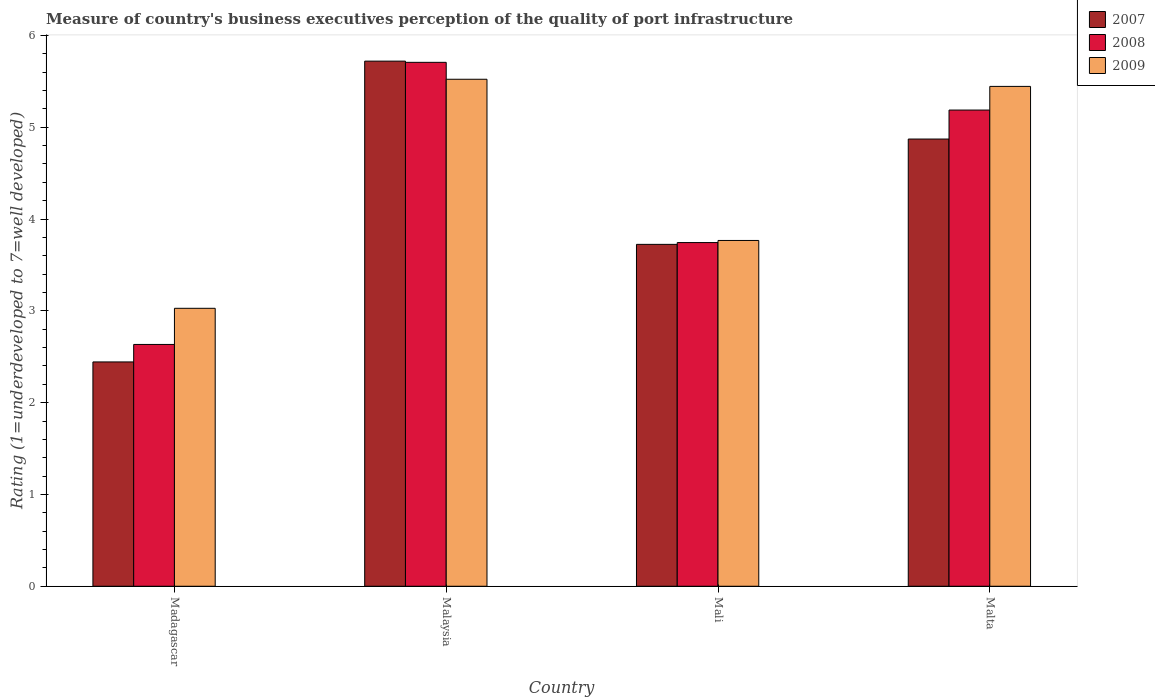How many groups of bars are there?
Your answer should be compact. 4. Are the number of bars per tick equal to the number of legend labels?
Make the answer very short. Yes. How many bars are there on the 2nd tick from the left?
Your response must be concise. 3. How many bars are there on the 2nd tick from the right?
Offer a very short reply. 3. What is the label of the 3rd group of bars from the left?
Offer a very short reply. Mali. In how many cases, is the number of bars for a given country not equal to the number of legend labels?
Provide a short and direct response. 0. What is the ratings of the quality of port infrastructure in 2009 in Malaysia?
Provide a succinct answer. 5.52. Across all countries, what is the maximum ratings of the quality of port infrastructure in 2009?
Offer a terse response. 5.52. Across all countries, what is the minimum ratings of the quality of port infrastructure in 2007?
Provide a short and direct response. 2.44. In which country was the ratings of the quality of port infrastructure in 2007 maximum?
Provide a short and direct response. Malaysia. In which country was the ratings of the quality of port infrastructure in 2007 minimum?
Your answer should be very brief. Madagascar. What is the total ratings of the quality of port infrastructure in 2007 in the graph?
Your answer should be compact. 16.76. What is the difference between the ratings of the quality of port infrastructure in 2009 in Madagascar and that in Malaysia?
Offer a terse response. -2.5. What is the difference between the ratings of the quality of port infrastructure in 2009 in Malta and the ratings of the quality of port infrastructure in 2007 in Madagascar?
Make the answer very short. 3. What is the average ratings of the quality of port infrastructure in 2008 per country?
Make the answer very short. 4.32. What is the difference between the ratings of the quality of port infrastructure of/in 2009 and ratings of the quality of port infrastructure of/in 2007 in Malaysia?
Offer a very short reply. -0.2. What is the ratio of the ratings of the quality of port infrastructure in 2009 in Madagascar to that in Mali?
Ensure brevity in your answer.  0.8. What is the difference between the highest and the second highest ratings of the quality of port infrastructure in 2008?
Keep it short and to the point. 1.44. What is the difference between the highest and the lowest ratings of the quality of port infrastructure in 2008?
Ensure brevity in your answer.  3.07. In how many countries, is the ratings of the quality of port infrastructure in 2007 greater than the average ratings of the quality of port infrastructure in 2007 taken over all countries?
Provide a succinct answer. 2. What does the 3rd bar from the left in Madagascar represents?
Ensure brevity in your answer.  2009. Are all the bars in the graph horizontal?
Your answer should be compact. No. Does the graph contain any zero values?
Your response must be concise. No. How are the legend labels stacked?
Your answer should be very brief. Vertical. What is the title of the graph?
Offer a very short reply. Measure of country's business executives perception of the quality of port infrastructure. Does "2014" appear as one of the legend labels in the graph?
Your answer should be very brief. No. What is the label or title of the Y-axis?
Your answer should be compact. Rating (1=underdeveloped to 7=well developed). What is the Rating (1=underdeveloped to 7=well developed) in 2007 in Madagascar?
Ensure brevity in your answer.  2.44. What is the Rating (1=underdeveloped to 7=well developed) of 2008 in Madagascar?
Offer a very short reply. 2.63. What is the Rating (1=underdeveloped to 7=well developed) of 2009 in Madagascar?
Provide a succinct answer. 3.03. What is the Rating (1=underdeveloped to 7=well developed) of 2007 in Malaysia?
Give a very brief answer. 5.72. What is the Rating (1=underdeveloped to 7=well developed) in 2008 in Malaysia?
Provide a succinct answer. 5.71. What is the Rating (1=underdeveloped to 7=well developed) in 2009 in Malaysia?
Your answer should be very brief. 5.52. What is the Rating (1=underdeveloped to 7=well developed) of 2007 in Mali?
Provide a short and direct response. 3.72. What is the Rating (1=underdeveloped to 7=well developed) in 2008 in Mali?
Your answer should be compact. 3.74. What is the Rating (1=underdeveloped to 7=well developed) of 2009 in Mali?
Provide a succinct answer. 3.77. What is the Rating (1=underdeveloped to 7=well developed) in 2007 in Malta?
Your answer should be very brief. 4.87. What is the Rating (1=underdeveloped to 7=well developed) of 2008 in Malta?
Your response must be concise. 5.19. What is the Rating (1=underdeveloped to 7=well developed) of 2009 in Malta?
Your answer should be very brief. 5.44. Across all countries, what is the maximum Rating (1=underdeveloped to 7=well developed) in 2007?
Ensure brevity in your answer.  5.72. Across all countries, what is the maximum Rating (1=underdeveloped to 7=well developed) of 2008?
Provide a succinct answer. 5.71. Across all countries, what is the maximum Rating (1=underdeveloped to 7=well developed) in 2009?
Make the answer very short. 5.52. Across all countries, what is the minimum Rating (1=underdeveloped to 7=well developed) in 2007?
Your response must be concise. 2.44. Across all countries, what is the minimum Rating (1=underdeveloped to 7=well developed) in 2008?
Provide a succinct answer. 2.63. Across all countries, what is the minimum Rating (1=underdeveloped to 7=well developed) in 2009?
Your response must be concise. 3.03. What is the total Rating (1=underdeveloped to 7=well developed) of 2007 in the graph?
Offer a terse response. 16.76. What is the total Rating (1=underdeveloped to 7=well developed) of 2008 in the graph?
Make the answer very short. 17.27. What is the total Rating (1=underdeveloped to 7=well developed) in 2009 in the graph?
Your response must be concise. 17.76. What is the difference between the Rating (1=underdeveloped to 7=well developed) of 2007 in Madagascar and that in Malaysia?
Your answer should be compact. -3.28. What is the difference between the Rating (1=underdeveloped to 7=well developed) of 2008 in Madagascar and that in Malaysia?
Your answer should be very brief. -3.07. What is the difference between the Rating (1=underdeveloped to 7=well developed) in 2009 in Madagascar and that in Malaysia?
Ensure brevity in your answer.  -2.5. What is the difference between the Rating (1=underdeveloped to 7=well developed) in 2007 in Madagascar and that in Mali?
Provide a short and direct response. -1.28. What is the difference between the Rating (1=underdeveloped to 7=well developed) of 2008 in Madagascar and that in Mali?
Provide a short and direct response. -1.11. What is the difference between the Rating (1=underdeveloped to 7=well developed) of 2009 in Madagascar and that in Mali?
Ensure brevity in your answer.  -0.74. What is the difference between the Rating (1=underdeveloped to 7=well developed) in 2007 in Madagascar and that in Malta?
Provide a succinct answer. -2.43. What is the difference between the Rating (1=underdeveloped to 7=well developed) of 2008 in Madagascar and that in Malta?
Your response must be concise. -2.55. What is the difference between the Rating (1=underdeveloped to 7=well developed) of 2009 in Madagascar and that in Malta?
Offer a terse response. -2.42. What is the difference between the Rating (1=underdeveloped to 7=well developed) in 2007 in Malaysia and that in Mali?
Give a very brief answer. 2. What is the difference between the Rating (1=underdeveloped to 7=well developed) in 2008 in Malaysia and that in Mali?
Offer a terse response. 1.96. What is the difference between the Rating (1=underdeveloped to 7=well developed) of 2009 in Malaysia and that in Mali?
Keep it short and to the point. 1.76. What is the difference between the Rating (1=underdeveloped to 7=well developed) of 2007 in Malaysia and that in Malta?
Offer a terse response. 0.85. What is the difference between the Rating (1=underdeveloped to 7=well developed) in 2008 in Malaysia and that in Malta?
Your answer should be compact. 0.52. What is the difference between the Rating (1=underdeveloped to 7=well developed) of 2009 in Malaysia and that in Malta?
Make the answer very short. 0.08. What is the difference between the Rating (1=underdeveloped to 7=well developed) of 2007 in Mali and that in Malta?
Offer a very short reply. -1.15. What is the difference between the Rating (1=underdeveloped to 7=well developed) of 2008 in Mali and that in Malta?
Make the answer very short. -1.44. What is the difference between the Rating (1=underdeveloped to 7=well developed) of 2009 in Mali and that in Malta?
Offer a terse response. -1.68. What is the difference between the Rating (1=underdeveloped to 7=well developed) in 2007 in Madagascar and the Rating (1=underdeveloped to 7=well developed) in 2008 in Malaysia?
Offer a terse response. -3.26. What is the difference between the Rating (1=underdeveloped to 7=well developed) of 2007 in Madagascar and the Rating (1=underdeveloped to 7=well developed) of 2009 in Malaysia?
Offer a very short reply. -3.08. What is the difference between the Rating (1=underdeveloped to 7=well developed) of 2008 in Madagascar and the Rating (1=underdeveloped to 7=well developed) of 2009 in Malaysia?
Offer a very short reply. -2.89. What is the difference between the Rating (1=underdeveloped to 7=well developed) in 2007 in Madagascar and the Rating (1=underdeveloped to 7=well developed) in 2008 in Mali?
Your answer should be very brief. -1.3. What is the difference between the Rating (1=underdeveloped to 7=well developed) of 2007 in Madagascar and the Rating (1=underdeveloped to 7=well developed) of 2009 in Mali?
Offer a very short reply. -1.32. What is the difference between the Rating (1=underdeveloped to 7=well developed) of 2008 in Madagascar and the Rating (1=underdeveloped to 7=well developed) of 2009 in Mali?
Provide a short and direct response. -1.13. What is the difference between the Rating (1=underdeveloped to 7=well developed) in 2007 in Madagascar and the Rating (1=underdeveloped to 7=well developed) in 2008 in Malta?
Provide a short and direct response. -2.74. What is the difference between the Rating (1=underdeveloped to 7=well developed) in 2007 in Madagascar and the Rating (1=underdeveloped to 7=well developed) in 2009 in Malta?
Your response must be concise. -3. What is the difference between the Rating (1=underdeveloped to 7=well developed) in 2008 in Madagascar and the Rating (1=underdeveloped to 7=well developed) in 2009 in Malta?
Ensure brevity in your answer.  -2.81. What is the difference between the Rating (1=underdeveloped to 7=well developed) of 2007 in Malaysia and the Rating (1=underdeveloped to 7=well developed) of 2008 in Mali?
Your answer should be very brief. 1.98. What is the difference between the Rating (1=underdeveloped to 7=well developed) in 2007 in Malaysia and the Rating (1=underdeveloped to 7=well developed) in 2009 in Mali?
Give a very brief answer. 1.95. What is the difference between the Rating (1=underdeveloped to 7=well developed) in 2008 in Malaysia and the Rating (1=underdeveloped to 7=well developed) in 2009 in Mali?
Keep it short and to the point. 1.94. What is the difference between the Rating (1=underdeveloped to 7=well developed) in 2007 in Malaysia and the Rating (1=underdeveloped to 7=well developed) in 2008 in Malta?
Offer a terse response. 0.53. What is the difference between the Rating (1=underdeveloped to 7=well developed) of 2007 in Malaysia and the Rating (1=underdeveloped to 7=well developed) of 2009 in Malta?
Offer a very short reply. 0.28. What is the difference between the Rating (1=underdeveloped to 7=well developed) in 2008 in Malaysia and the Rating (1=underdeveloped to 7=well developed) in 2009 in Malta?
Your answer should be compact. 0.26. What is the difference between the Rating (1=underdeveloped to 7=well developed) of 2007 in Mali and the Rating (1=underdeveloped to 7=well developed) of 2008 in Malta?
Offer a terse response. -1.46. What is the difference between the Rating (1=underdeveloped to 7=well developed) of 2007 in Mali and the Rating (1=underdeveloped to 7=well developed) of 2009 in Malta?
Ensure brevity in your answer.  -1.72. What is the difference between the Rating (1=underdeveloped to 7=well developed) of 2008 in Mali and the Rating (1=underdeveloped to 7=well developed) of 2009 in Malta?
Keep it short and to the point. -1.7. What is the average Rating (1=underdeveloped to 7=well developed) in 2007 per country?
Ensure brevity in your answer.  4.19. What is the average Rating (1=underdeveloped to 7=well developed) in 2008 per country?
Make the answer very short. 4.32. What is the average Rating (1=underdeveloped to 7=well developed) of 2009 per country?
Ensure brevity in your answer.  4.44. What is the difference between the Rating (1=underdeveloped to 7=well developed) in 2007 and Rating (1=underdeveloped to 7=well developed) in 2008 in Madagascar?
Offer a very short reply. -0.19. What is the difference between the Rating (1=underdeveloped to 7=well developed) in 2007 and Rating (1=underdeveloped to 7=well developed) in 2009 in Madagascar?
Provide a succinct answer. -0.58. What is the difference between the Rating (1=underdeveloped to 7=well developed) of 2008 and Rating (1=underdeveloped to 7=well developed) of 2009 in Madagascar?
Offer a very short reply. -0.39. What is the difference between the Rating (1=underdeveloped to 7=well developed) of 2007 and Rating (1=underdeveloped to 7=well developed) of 2008 in Malaysia?
Provide a short and direct response. 0.01. What is the difference between the Rating (1=underdeveloped to 7=well developed) in 2007 and Rating (1=underdeveloped to 7=well developed) in 2009 in Malaysia?
Your answer should be compact. 0.2. What is the difference between the Rating (1=underdeveloped to 7=well developed) of 2008 and Rating (1=underdeveloped to 7=well developed) of 2009 in Malaysia?
Offer a terse response. 0.18. What is the difference between the Rating (1=underdeveloped to 7=well developed) of 2007 and Rating (1=underdeveloped to 7=well developed) of 2008 in Mali?
Make the answer very short. -0.02. What is the difference between the Rating (1=underdeveloped to 7=well developed) in 2007 and Rating (1=underdeveloped to 7=well developed) in 2009 in Mali?
Offer a very short reply. -0.04. What is the difference between the Rating (1=underdeveloped to 7=well developed) of 2008 and Rating (1=underdeveloped to 7=well developed) of 2009 in Mali?
Make the answer very short. -0.02. What is the difference between the Rating (1=underdeveloped to 7=well developed) of 2007 and Rating (1=underdeveloped to 7=well developed) of 2008 in Malta?
Give a very brief answer. -0.32. What is the difference between the Rating (1=underdeveloped to 7=well developed) of 2007 and Rating (1=underdeveloped to 7=well developed) of 2009 in Malta?
Offer a very short reply. -0.57. What is the difference between the Rating (1=underdeveloped to 7=well developed) of 2008 and Rating (1=underdeveloped to 7=well developed) of 2009 in Malta?
Give a very brief answer. -0.26. What is the ratio of the Rating (1=underdeveloped to 7=well developed) of 2007 in Madagascar to that in Malaysia?
Provide a short and direct response. 0.43. What is the ratio of the Rating (1=underdeveloped to 7=well developed) of 2008 in Madagascar to that in Malaysia?
Offer a very short reply. 0.46. What is the ratio of the Rating (1=underdeveloped to 7=well developed) in 2009 in Madagascar to that in Malaysia?
Offer a very short reply. 0.55. What is the ratio of the Rating (1=underdeveloped to 7=well developed) of 2007 in Madagascar to that in Mali?
Your answer should be compact. 0.66. What is the ratio of the Rating (1=underdeveloped to 7=well developed) in 2008 in Madagascar to that in Mali?
Make the answer very short. 0.7. What is the ratio of the Rating (1=underdeveloped to 7=well developed) in 2009 in Madagascar to that in Mali?
Ensure brevity in your answer.  0.8. What is the ratio of the Rating (1=underdeveloped to 7=well developed) of 2007 in Madagascar to that in Malta?
Your answer should be very brief. 0.5. What is the ratio of the Rating (1=underdeveloped to 7=well developed) in 2008 in Madagascar to that in Malta?
Make the answer very short. 0.51. What is the ratio of the Rating (1=underdeveloped to 7=well developed) in 2009 in Madagascar to that in Malta?
Keep it short and to the point. 0.56. What is the ratio of the Rating (1=underdeveloped to 7=well developed) in 2007 in Malaysia to that in Mali?
Offer a very short reply. 1.54. What is the ratio of the Rating (1=underdeveloped to 7=well developed) in 2008 in Malaysia to that in Mali?
Your answer should be very brief. 1.52. What is the ratio of the Rating (1=underdeveloped to 7=well developed) in 2009 in Malaysia to that in Mali?
Provide a short and direct response. 1.47. What is the ratio of the Rating (1=underdeveloped to 7=well developed) of 2007 in Malaysia to that in Malta?
Your answer should be very brief. 1.17. What is the ratio of the Rating (1=underdeveloped to 7=well developed) of 2008 in Malaysia to that in Malta?
Keep it short and to the point. 1.1. What is the ratio of the Rating (1=underdeveloped to 7=well developed) in 2009 in Malaysia to that in Malta?
Your response must be concise. 1.01. What is the ratio of the Rating (1=underdeveloped to 7=well developed) in 2007 in Mali to that in Malta?
Keep it short and to the point. 0.76. What is the ratio of the Rating (1=underdeveloped to 7=well developed) of 2008 in Mali to that in Malta?
Offer a terse response. 0.72. What is the ratio of the Rating (1=underdeveloped to 7=well developed) in 2009 in Mali to that in Malta?
Offer a terse response. 0.69. What is the difference between the highest and the second highest Rating (1=underdeveloped to 7=well developed) in 2007?
Keep it short and to the point. 0.85. What is the difference between the highest and the second highest Rating (1=underdeveloped to 7=well developed) of 2008?
Offer a terse response. 0.52. What is the difference between the highest and the second highest Rating (1=underdeveloped to 7=well developed) of 2009?
Keep it short and to the point. 0.08. What is the difference between the highest and the lowest Rating (1=underdeveloped to 7=well developed) of 2007?
Keep it short and to the point. 3.28. What is the difference between the highest and the lowest Rating (1=underdeveloped to 7=well developed) in 2008?
Provide a succinct answer. 3.07. What is the difference between the highest and the lowest Rating (1=underdeveloped to 7=well developed) of 2009?
Give a very brief answer. 2.5. 